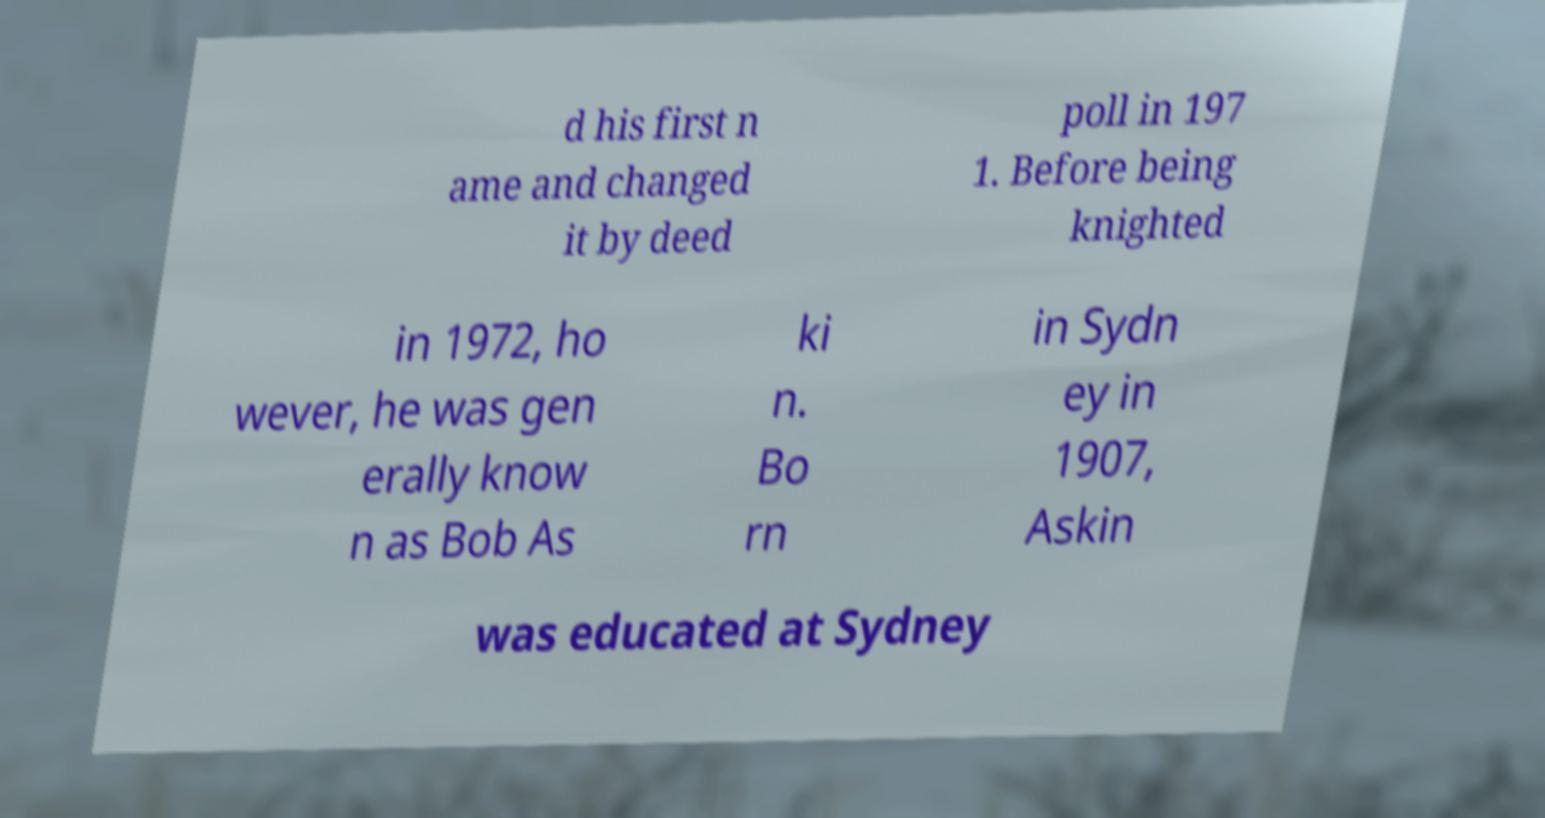Could you assist in decoding the text presented in this image and type it out clearly? d his first n ame and changed it by deed poll in 197 1. Before being knighted in 1972, ho wever, he was gen erally know n as Bob As ki n. Bo rn in Sydn ey in 1907, Askin was educated at Sydney 